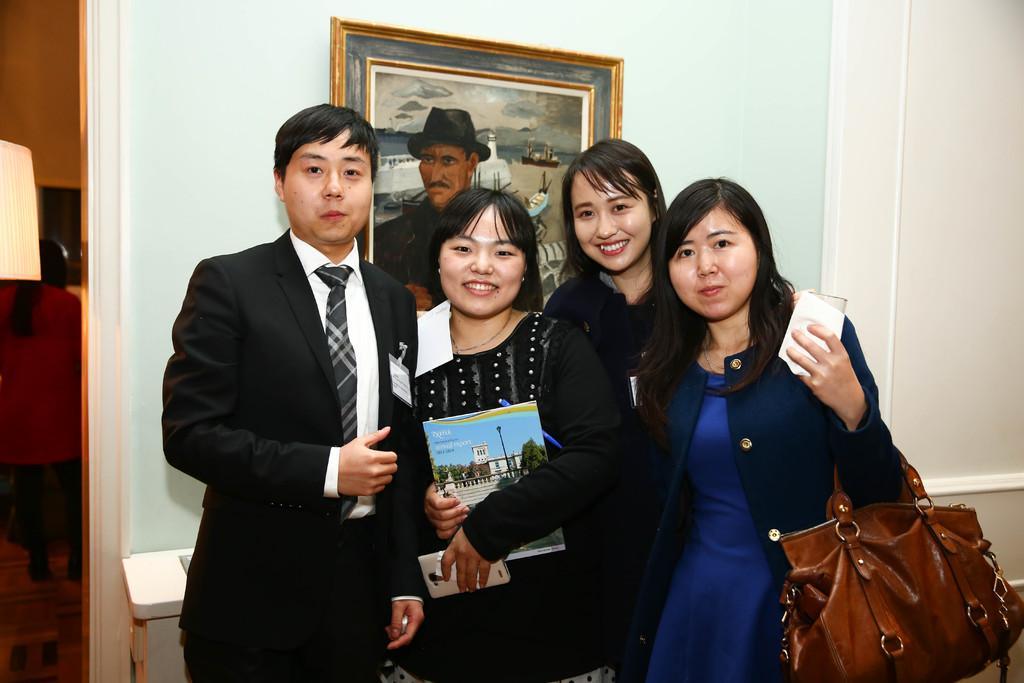How would you summarize this image in a sentence or two? In this picture there are group of people, they are taking a snap at the center of the image, there is a portrait behind the people at the center of the image and there is a door at the left side of the image. 